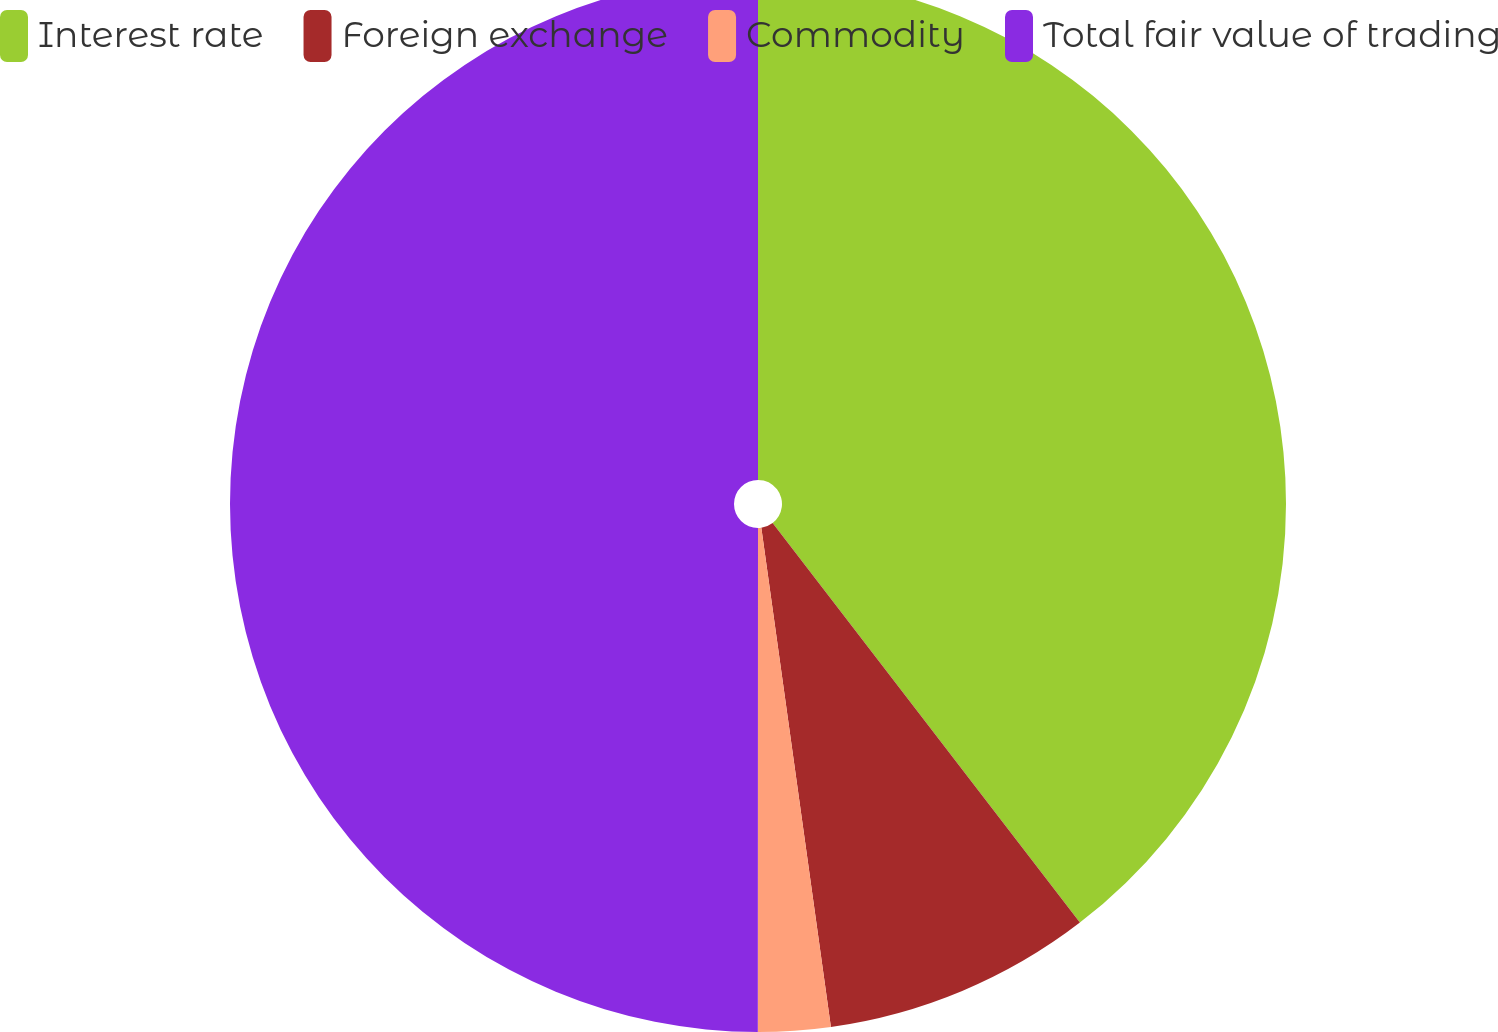Convert chart. <chart><loc_0><loc_0><loc_500><loc_500><pie_chart><fcel>Interest rate<fcel>Foreign exchange<fcel>Commodity<fcel>Total fair value of trading<nl><fcel>39.57%<fcel>8.23%<fcel>2.21%<fcel>50.0%<nl></chart> 